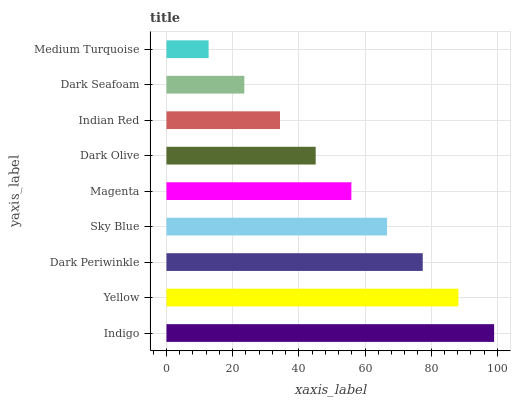Is Medium Turquoise the minimum?
Answer yes or no. Yes. Is Indigo the maximum?
Answer yes or no. Yes. Is Yellow the minimum?
Answer yes or no. No. Is Yellow the maximum?
Answer yes or no. No. Is Indigo greater than Yellow?
Answer yes or no. Yes. Is Yellow less than Indigo?
Answer yes or no. Yes. Is Yellow greater than Indigo?
Answer yes or no. No. Is Indigo less than Yellow?
Answer yes or no. No. Is Magenta the high median?
Answer yes or no. Yes. Is Magenta the low median?
Answer yes or no. Yes. Is Yellow the high median?
Answer yes or no. No. Is Dark Periwinkle the low median?
Answer yes or no. No. 